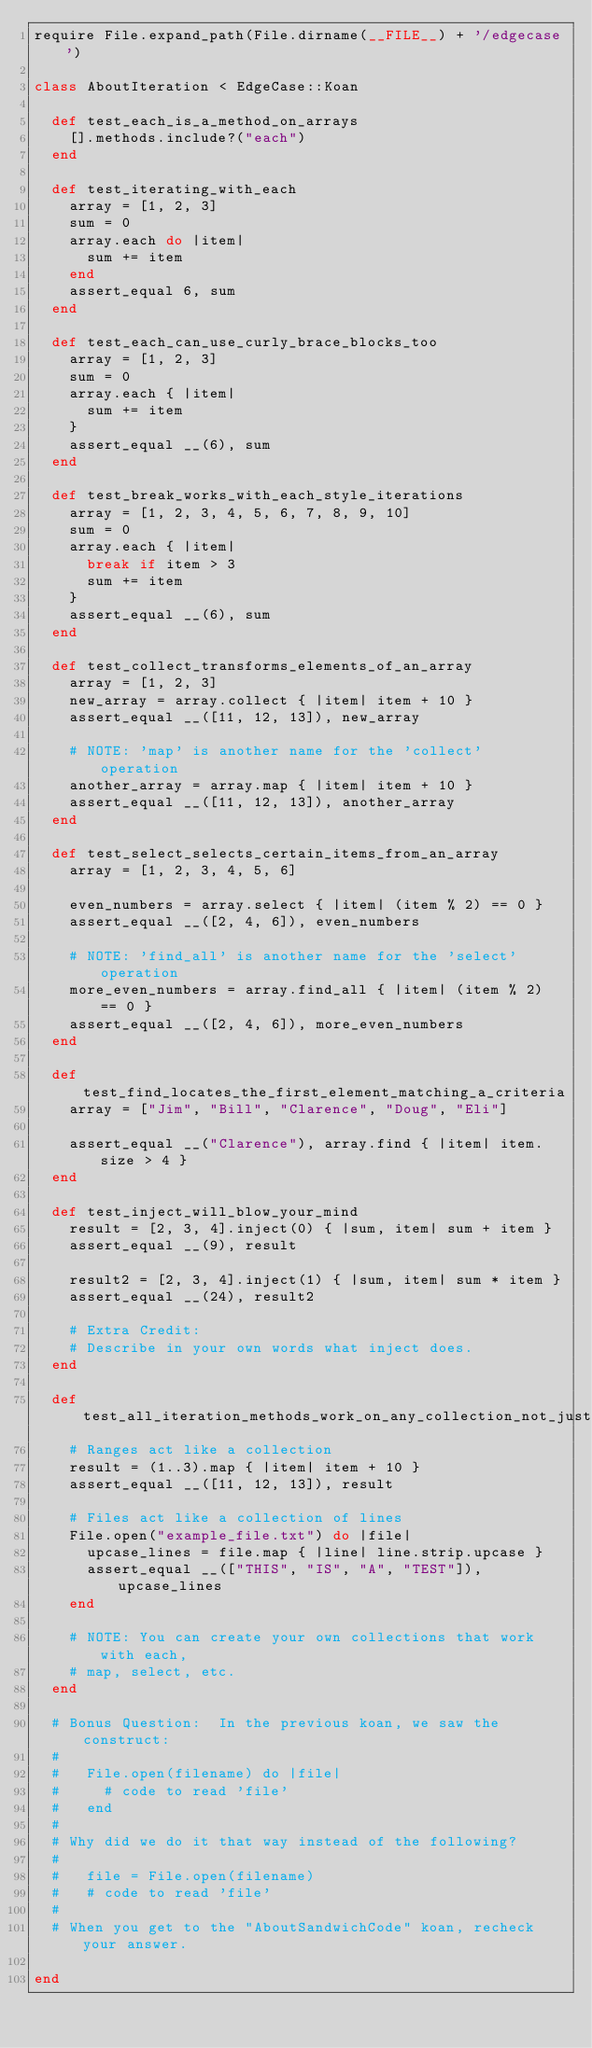<code> <loc_0><loc_0><loc_500><loc_500><_Ruby_>require File.expand_path(File.dirname(__FILE__) + '/edgecase')

class AboutIteration < EdgeCase::Koan

  def test_each_is_a_method_on_arrays
    [].methods.include?("each")
  end

  def test_iterating_with_each
    array = [1, 2, 3]
    sum = 0
    array.each do |item|
      sum += item
    end
    assert_equal 6, sum
  end

  def test_each_can_use_curly_brace_blocks_too
    array = [1, 2, 3]
    sum = 0
    array.each { |item|
      sum += item
    }
    assert_equal __(6), sum
  end

  def test_break_works_with_each_style_iterations
    array = [1, 2, 3, 4, 5, 6, 7, 8, 9, 10]
    sum = 0
    array.each { |item|
      break if item > 3
      sum += item
    }
    assert_equal __(6), sum
  end

  def test_collect_transforms_elements_of_an_array
    array = [1, 2, 3]
    new_array = array.collect { |item| item + 10 }
    assert_equal __([11, 12, 13]), new_array

    # NOTE: 'map' is another name for the 'collect' operation
    another_array = array.map { |item| item + 10 }
    assert_equal __([11, 12, 13]), another_array
  end

  def test_select_selects_certain_items_from_an_array
    array = [1, 2, 3, 4, 5, 6]

    even_numbers = array.select { |item| (item % 2) == 0 }
    assert_equal __([2, 4, 6]), even_numbers

    # NOTE: 'find_all' is another name for the 'select' operation
    more_even_numbers = array.find_all { |item| (item % 2) == 0 }
    assert_equal __([2, 4, 6]), more_even_numbers
  end

  def test_find_locates_the_first_element_matching_a_criteria
    array = ["Jim", "Bill", "Clarence", "Doug", "Eli"]

    assert_equal __("Clarence"), array.find { |item| item.size > 4 }
  end

  def test_inject_will_blow_your_mind
    result = [2, 3, 4].inject(0) { |sum, item| sum + item }
    assert_equal __(9), result

    result2 = [2, 3, 4].inject(1) { |sum, item| sum * item }
    assert_equal __(24), result2

    # Extra Credit:
    # Describe in your own words what inject does.
  end

  def test_all_iteration_methods_work_on_any_collection_not_just_arrays
    # Ranges act like a collection
    result = (1..3).map { |item| item + 10 }
    assert_equal __([11, 12, 13]), result

    # Files act like a collection of lines
    File.open("example_file.txt") do |file|
      upcase_lines = file.map { |line| line.strip.upcase }
      assert_equal __(["THIS", "IS", "A", "TEST"]), upcase_lines
    end

    # NOTE: You can create your own collections that work with each,
    # map, select, etc.
  end

  # Bonus Question:  In the previous koan, we saw the construct:
  #
  #   File.open(filename) do |file|
  #     # code to read 'file'
  #   end
  #
  # Why did we do it that way instead of the following?
  #
  #   file = File.open(filename)
  #   # code to read 'file'
  #
  # When you get to the "AboutSandwichCode" koan, recheck your answer.

end
</code> 